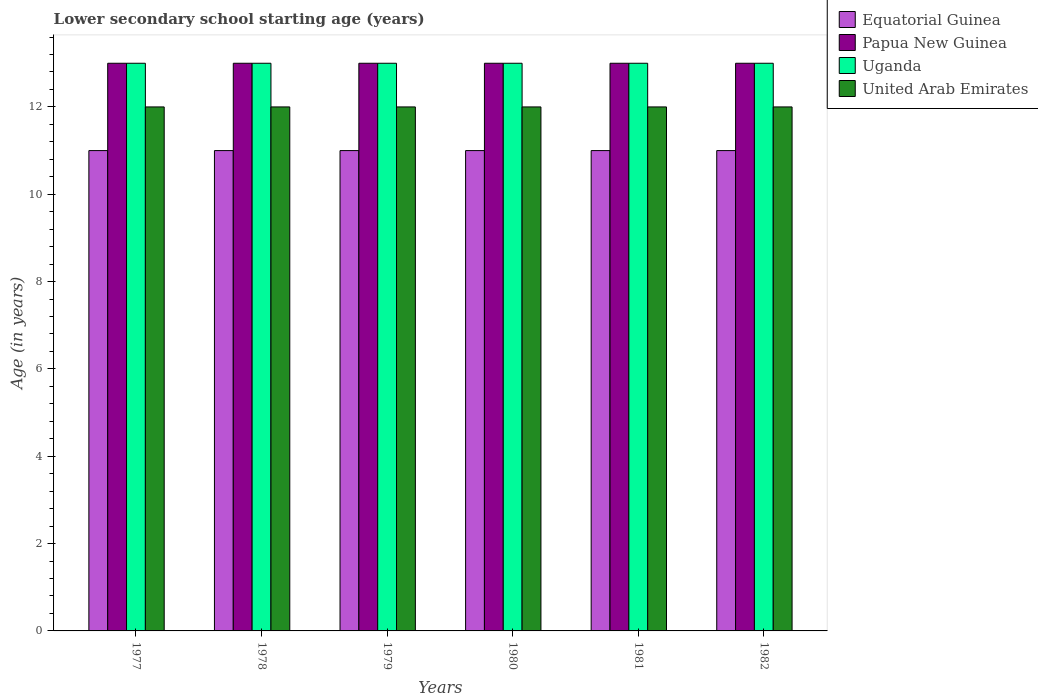How many different coloured bars are there?
Make the answer very short. 4. How many groups of bars are there?
Provide a succinct answer. 6. What is the label of the 6th group of bars from the left?
Ensure brevity in your answer.  1982. What is the lower secondary school starting age of children in Equatorial Guinea in 1978?
Your answer should be compact. 11. Across all years, what is the maximum lower secondary school starting age of children in Uganda?
Provide a succinct answer. 13. Across all years, what is the minimum lower secondary school starting age of children in Papua New Guinea?
Offer a terse response. 13. What is the total lower secondary school starting age of children in United Arab Emirates in the graph?
Offer a very short reply. 72. What is the difference between the lower secondary school starting age of children in Uganda in 1981 and the lower secondary school starting age of children in Equatorial Guinea in 1978?
Ensure brevity in your answer.  2. What is the average lower secondary school starting age of children in United Arab Emirates per year?
Your answer should be very brief. 12. In the year 1980, what is the difference between the lower secondary school starting age of children in Equatorial Guinea and lower secondary school starting age of children in Papua New Guinea?
Ensure brevity in your answer.  -2. What is the ratio of the lower secondary school starting age of children in Papua New Guinea in 1979 to that in 1980?
Make the answer very short. 1. Is the lower secondary school starting age of children in Equatorial Guinea in 1977 less than that in 1979?
Give a very brief answer. No. Is the difference between the lower secondary school starting age of children in Equatorial Guinea in 1980 and 1981 greater than the difference between the lower secondary school starting age of children in Papua New Guinea in 1980 and 1981?
Your answer should be compact. No. What is the difference between the highest and the second highest lower secondary school starting age of children in Uganda?
Offer a terse response. 0. What is the difference between the highest and the lowest lower secondary school starting age of children in United Arab Emirates?
Offer a terse response. 0. In how many years, is the lower secondary school starting age of children in Uganda greater than the average lower secondary school starting age of children in Uganda taken over all years?
Offer a very short reply. 0. What does the 3rd bar from the left in 1980 represents?
Offer a terse response. Uganda. What does the 2nd bar from the right in 1979 represents?
Your answer should be compact. Uganda. How many years are there in the graph?
Your answer should be very brief. 6. What is the difference between two consecutive major ticks on the Y-axis?
Keep it short and to the point. 2. Are the values on the major ticks of Y-axis written in scientific E-notation?
Your answer should be very brief. No. Does the graph contain any zero values?
Your answer should be compact. No. How many legend labels are there?
Your answer should be very brief. 4. What is the title of the graph?
Offer a terse response. Lower secondary school starting age (years). Does "Solomon Islands" appear as one of the legend labels in the graph?
Provide a short and direct response. No. What is the label or title of the X-axis?
Your answer should be compact. Years. What is the label or title of the Y-axis?
Ensure brevity in your answer.  Age (in years). What is the Age (in years) in Uganda in 1977?
Offer a terse response. 13. What is the Age (in years) in Papua New Guinea in 1978?
Provide a short and direct response. 13. What is the Age (in years) of Uganda in 1978?
Keep it short and to the point. 13. What is the Age (in years) of United Arab Emirates in 1978?
Offer a terse response. 12. What is the Age (in years) of Equatorial Guinea in 1979?
Ensure brevity in your answer.  11. What is the Age (in years) of Uganda in 1979?
Provide a succinct answer. 13. What is the Age (in years) of Papua New Guinea in 1980?
Offer a terse response. 13. What is the Age (in years) in United Arab Emirates in 1980?
Make the answer very short. 12. What is the Age (in years) of Papua New Guinea in 1981?
Give a very brief answer. 13. What is the Age (in years) in United Arab Emirates in 1981?
Your answer should be compact. 12. What is the Age (in years) of Equatorial Guinea in 1982?
Offer a terse response. 11. What is the Age (in years) in Papua New Guinea in 1982?
Your answer should be very brief. 13. What is the Age (in years) in United Arab Emirates in 1982?
Provide a short and direct response. 12. Across all years, what is the maximum Age (in years) in Papua New Guinea?
Keep it short and to the point. 13. Across all years, what is the maximum Age (in years) in United Arab Emirates?
Ensure brevity in your answer.  12. Across all years, what is the minimum Age (in years) in Equatorial Guinea?
Your answer should be compact. 11. Across all years, what is the minimum Age (in years) in Uganda?
Provide a short and direct response. 13. Across all years, what is the minimum Age (in years) of United Arab Emirates?
Your response must be concise. 12. What is the total Age (in years) in Equatorial Guinea in the graph?
Offer a very short reply. 66. What is the total Age (in years) in Uganda in the graph?
Make the answer very short. 78. What is the total Age (in years) in United Arab Emirates in the graph?
Provide a short and direct response. 72. What is the difference between the Age (in years) of Equatorial Guinea in 1977 and that in 1978?
Make the answer very short. 0. What is the difference between the Age (in years) of Uganda in 1977 and that in 1978?
Your response must be concise. 0. What is the difference between the Age (in years) in Papua New Guinea in 1977 and that in 1979?
Give a very brief answer. 0. What is the difference between the Age (in years) of Uganda in 1977 and that in 1979?
Give a very brief answer. 0. What is the difference between the Age (in years) in United Arab Emirates in 1977 and that in 1979?
Offer a very short reply. 0. What is the difference between the Age (in years) of Equatorial Guinea in 1977 and that in 1981?
Provide a short and direct response. 0. What is the difference between the Age (in years) of Papua New Guinea in 1977 and that in 1981?
Your answer should be very brief. 0. What is the difference between the Age (in years) of Uganda in 1977 and that in 1981?
Your response must be concise. 0. What is the difference between the Age (in years) in United Arab Emirates in 1977 and that in 1981?
Give a very brief answer. 0. What is the difference between the Age (in years) in Equatorial Guinea in 1977 and that in 1982?
Offer a very short reply. 0. What is the difference between the Age (in years) in Papua New Guinea in 1977 and that in 1982?
Offer a very short reply. 0. What is the difference between the Age (in years) of Uganda in 1977 and that in 1982?
Keep it short and to the point. 0. What is the difference between the Age (in years) in Equatorial Guinea in 1978 and that in 1979?
Make the answer very short. 0. What is the difference between the Age (in years) in Papua New Guinea in 1978 and that in 1979?
Ensure brevity in your answer.  0. What is the difference between the Age (in years) in Uganda in 1978 and that in 1979?
Offer a terse response. 0. What is the difference between the Age (in years) in United Arab Emirates in 1978 and that in 1979?
Keep it short and to the point. 0. What is the difference between the Age (in years) in Equatorial Guinea in 1978 and that in 1980?
Provide a short and direct response. 0. What is the difference between the Age (in years) of Papua New Guinea in 1978 and that in 1980?
Your response must be concise. 0. What is the difference between the Age (in years) of Uganda in 1978 and that in 1980?
Your answer should be very brief. 0. What is the difference between the Age (in years) in Papua New Guinea in 1978 and that in 1981?
Ensure brevity in your answer.  0. What is the difference between the Age (in years) of United Arab Emirates in 1978 and that in 1981?
Make the answer very short. 0. What is the difference between the Age (in years) in Equatorial Guinea in 1978 and that in 1982?
Provide a short and direct response. 0. What is the difference between the Age (in years) in Equatorial Guinea in 1979 and that in 1980?
Ensure brevity in your answer.  0. What is the difference between the Age (in years) in Uganda in 1979 and that in 1980?
Provide a succinct answer. 0. What is the difference between the Age (in years) of Equatorial Guinea in 1979 and that in 1981?
Ensure brevity in your answer.  0. What is the difference between the Age (in years) of Uganda in 1979 and that in 1981?
Offer a very short reply. 0. What is the difference between the Age (in years) in United Arab Emirates in 1979 and that in 1981?
Your answer should be compact. 0. What is the difference between the Age (in years) in Papua New Guinea in 1979 and that in 1982?
Make the answer very short. 0. What is the difference between the Age (in years) of United Arab Emirates in 1979 and that in 1982?
Ensure brevity in your answer.  0. What is the difference between the Age (in years) of United Arab Emirates in 1980 and that in 1981?
Your answer should be compact. 0. What is the difference between the Age (in years) of Equatorial Guinea in 1980 and that in 1982?
Keep it short and to the point. 0. What is the difference between the Age (in years) of Papua New Guinea in 1980 and that in 1982?
Offer a terse response. 0. What is the difference between the Age (in years) of Uganda in 1980 and that in 1982?
Offer a terse response. 0. What is the difference between the Age (in years) of United Arab Emirates in 1980 and that in 1982?
Make the answer very short. 0. What is the difference between the Age (in years) of Equatorial Guinea in 1981 and that in 1982?
Make the answer very short. 0. What is the difference between the Age (in years) of Equatorial Guinea in 1977 and the Age (in years) of Uganda in 1978?
Your response must be concise. -2. What is the difference between the Age (in years) of Equatorial Guinea in 1977 and the Age (in years) of United Arab Emirates in 1978?
Your answer should be compact. -1. What is the difference between the Age (in years) in Papua New Guinea in 1977 and the Age (in years) in United Arab Emirates in 1978?
Your response must be concise. 1. What is the difference between the Age (in years) of Equatorial Guinea in 1977 and the Age (in years) of Papua New Guinea in 1979?
Your answer should be very brief. -2. What is the difference between the Age (in years) of Papua New Guinea in 1977 and the Age (in years) of Uganda in 1979?
Provide a succinct answer. 0. What is the difference between the Age (in years) in Papua New Guinea in 1977 and the Age (in years) in United Arab Emirates in 1979?
Your answer should be very brief. 1. What is the difference between the Age (in years) in Uganda in 1977 and the Age (in years) in United Arab Emirates in 1979?
Your response must be concise. 1. What is the difference between the Age (in years) of Equatorial Guinea in 1977 and the Age (in years) of Papua New Guinea in 1980?
Offer a very short reply. -2. What is the difference between the Age (in years) in Equatorial Guinea in 1977 and the Age (in years) in Uganda in 1980?
Your answer should be compact. -2. What is the difference between the Age (in years) of Papua New Guinea in 1977 and the Age (in years) of Uganda in 1980?
Provide a short and direct response. 0. What is the difference between the Age (in years) in Equatorial Guinea in 1977 and the Age (in years) in Papua New Guinea in 1981?
Provide a short and direct response. -2. What is the difference between the Age (in years) of Equatorial Guinea in 1977 and the Age (in years) of United Arab Emirates in 1981?
Make the answer very short. -1. What is the difference between the Age (in years) of Papua New Guinea in 1977 and the Age (in years) of Uganda in 1981?
Your answer should be compact. 0. What is the difference between the Age (in years) of Papua New Guinea in 1977 and the Age (in years) of United Arab Emirates in 1981?
Keep it short and to the point. 1. What is the difference between the Age (in years) in Equatorial Guinea in 1977 and the Age (in years) in Uganda in 1982?
Make the answer very short. -2. What is the difference between the Age (in years) of Equatorial Guinea in 1977 and the Age (in years) of United Arab Emirates in 1982?
Make the answer very short. -1. What is the difference between the Age (in years) of Uganda in 1977 and the Age (in years) of United Arab Emirates in 1982?
Your response must be concise. 1. What is the difference between the Age (in years) of Equatorial Guinea in 1978 and the Age (in years) of United Arab Emirates in 1979?
Give a very brief answer. -1. What is the difference between the Age (in years) of Papua New Guinea in 1978 and the Age (in years) of United Arab Emirates in 1979?
Your answer should be very brief. 1. What is the difference between the Age (in years) in Uganda in 1978 and the Age (in years) in United Arab Emirates in 1979?
Offer a very short reply. 1. What is the difference between the Age (in years) in Equatorial Guinea in 1978 and the Age (in years) in Papua New Guinea in 1980?
Offer a terse response. -2. What is the difference between the Age (in years) of Equatorial Guinea in 1978 and the Age (in years) of United Arab Emirates in 1980?
Provide a short and direct response. -1. What is the difference between the Age (in years) in Papua New Guinea in 1978 and the Age (in years) in Uganda in 1980?
Your answer should be compact. 0. What is the difference between the Age (in years) in Papua New Guinea in 1978 and the Age (in years) in United Arab Emirates in 1980?
Offer a very short reply. 1. What is the difference between the Age (in years) of Equatorial Guinea in 1978 and the Age (in years) of United Arab Emirates in 1981?
Make the answer very short. -1. What is the difference between the Age (in years) in Equatorial Guinea in 1978 and the Age (in years) in United Arab Emirates in 1982?
Make the answer very short. -1. What is the difference between the Age (in years) of Papua New Guinea in 1978 and the Age (in years) of Uganda in 1982?
Make the answer very short. 0. What is the difference between the Age (in years) of Uganda in 1978 and the Age (in years) of United Arab Emirates in 1982?
Your answer should be very brief. 1. What is the difference between the Age (in years) of Equatorial Guinea in 1979 and the Age (in years) of United Arab Emirates in 1980?
Offer a very short reply. -1. What is the difference between the Age (in years) in Papua New Guinea in 1979 and the Age (in years) in Uganda in 1980?
Your answer should be very brief. 0. What is the difference between the Age (in years) in Papua New Guinea in 1979 and the Age (in years) in United Arab Emirates in 1980?
Offer a very short reply. 1. What is the difference between the Age (in years) of Equatorial Guinea in 1979 and the Age (in years) of Uganda in 1981?
Your answer should be very brief. -2. What is the difference between the Age (in years) of Papua New Guinea in 1979 and the Age (in years) of United Arab Emirates in 1981?
Provide a short and direct response. 1. What is the difference between the Age (in years) of Uganda in 1979 and the Age (in years) of United Arab Emirates in 1981?
Offer a very short reply. 1. What is the difference between the Age (in years) in Equatorial Guinea in 1979 and the Age (in years) in Papua New Guinea in 1982?
Provide a succinct answer. -2. What is the difference between the Age (in years) of Equatorial Guinea in 1979 and the Age (in years) of Uganda in 1982?
Provide a short and direct response. -2. What is the difference between the Age (in years) of Equatorial Guinea in 1979 and the Age (in years) of United Arab Emirates in 1982?
Keep it short and to the point. -1. What is the difference between the Age (in years) in Uganda in 1979 and the Age (in years) in United Arab Emirates in 1982?
Offer a very short reply. 1. What is the difference between the Age (in years) in Equatorial Guinea in 1980 and the Age (in years) in Papua New Guinea in 1981?
Offer a terse response. -2. What is the difference between the Age (in years) of Equatorial Guinea in 1980 and the Age (in years) of United Arab Emirates in 1981?
Give a very brief answer. -1. What is the difference between the Age (in years) of Equatorial Guinea in 1980 and the Age (in years) of Uganda in 1982?
Provide a succinct answer. -2. What is the difference between the Age (in years) of Papua New Guinea in 1980 and the Age (in years) of Uganda in 1982?
Offer a very short reply. 0. What is the difference between the Age (in years) in Papua New Guinea in 1980 and the Age (in years) in United Arab Emirates in 1982?
Keep it short and to the point. 1. What is the difference between the Age (in years) of Uganda in 1980 and the Age (in years) of United Arab Emirates in 1982?
Your response must be concise. 1. What is the difference between the Age (in years) of Papua New Guinea in 1981 and the Age (in years) of Uganda in 1982?
Ensure brevity in your answer.  0. What is the difference between the Age (in years) of Uganda in 1981 and the Age (in years) of United Arab Emirates in 1982?
Your answer should be compact. 1. What is the average Age (in years) in Equatorial Guinea per year?
Make the answer very short. 11. What is the average Age (in years) in United Arab Emirates per year?
Offer a terse response. 12. In the year 1977, what is the difference between the Age (in years) of Papua New Guinea and Age (in years) of United Arab Emirates?
Provide a short and direct response. 1. In the year 1978, what is the difference between the Age (in years) of Equatorial Guinea and Age (in years) of Papua New Guinea?
Keep it short and to the point. -2. In the year 1978, what is the difference between the Age (in years) in Equatorial Guinea and Age (in years) in United Arab Emirates?
Offer a terse response. -1. In the year 1978, what is the difference between the Age (in years) of Papua New Guinea and Age (in years) of Uganda?
Ensure brevity in your answer.  0. In the year 1979, what is the difference between the Age (in years) of Equatorial Guinea and Age (in years) of Papua New Guinea?
Ensure brevity in your answer.  -2. In the year 1979, what is the difference between the Age (in years) in Equatorial Guinea and Age (in years) in Uganda?
Your answer should be very brief. -2. In the year 1980, what is the difference between the Age (in years) in Equatorial Guinea and Age (in years) in Uganda?
Provide a short and direct response. -2. In the year 1980, what is the difference between the Age (in years) of Equatorial Guinea and Age (in years) of United Arab Emirates?
Keep it short and to the point. -1. In the year 1980, what is the difference between the Age (in years) of Papua New Guinea and Age (in years) of Uganda?
Give a very brief answer. 0. In the year 1980, what is the difference between the Age (in years) in Papua New Guinea and Age (in years) in United Arab Emirates?
Give a very brief answer. 1. In the year 1981, what is the difference between the Age (in years) in Equatorial Guinea and Age (in years) in Uganda?
Make the answer very short. -2. In the year 1981, what is the difference between the Age (in years) in Papua New Guinea and Age (in years) in United Arab Emirates?
Your answer should be very brief. 1. In the year 1982, what is the difference between the Age (in years) in Equatorial Guinea and Age (in years) in Papua New Guinea?
Offer a terse response. -2. In the year 1982, what is the difference between the Age (in years) of Uganda and Age (in years) of United Arab Emirates?
Offer a very short reply. 1. What is the ratio of the Age (in years) of Equatorial Guinea in 1977 to that in 1978?
Your response must be concise. 1. What is the ratio of the Age (in years) of United Arab Emirates in 1977 to that in 1978?
Provide a succinct answer. 1. What is the ratio of the Age (in years) in Papua New Guinea in 1977 to that in 1979?
Provide a succinct answer. 1. What is the ratio of the Age (in years) of Uganda in 1977 to that in 1979?
Ensure brevity in your answer.  1. What is the ratio of the Age (in years) of United Arab Emirates in 1977 to that in 1979?
Provide a short and direct response. 1. What is the ratio of the Age (in years) in Equatorial Guinea in 1977 to that in 1980?
Your answer should be compact. 1. What is the ratio of the Age (in years) of Papua New Guinea in 1977 to that in 1980?
Make the answer very short. 1. What is the ratio of the Age (in years) of United Arab Emirates in 1977 to that in 1980?
Offer a terse response. 1. What is the ratio of the Age (in years) in United Arab Emirates in 1977 to that in 1981?
Offer a very short reply. 1. What is the ratio of the Age (in years) in Papua New Guinea in 1977 to that in 1982?
Give a very brief answer. 1. What is the ratio of the Age (in years) of Uganda in 1977 to that in 1982?
Keep it short and to the point. 1. What is the ratio of the Age (in years) in Papua New Guinea in 1978 to that in 1979?
Make the answer very short. 1. What is the ratio of the Age (in years) in Uganda in 1978 to that in 1979?
Give a very brief answer. 1. What is the ratio of the Age (in years) of Equatorial Guinea in 1978 to that in 1980?
Give a very brief answer. 1. What is the ratio of the Age (in years) in Papua New Guinea in 1978 to that in 1980?
Your response must be concise. 1. What is the ratio of the Age (in years) of Uganda in 1978 to that in 1980?
Make the answer very short. 1. What is the ratio of the Age (in years) of United Arab Emirates in 1978 to that in 1980?
Offer a very short reply. 1. What is the ratio of the Age (in years) of Uganda in 1978 to that in 1981?
Make the answer very short. 1. What is the ratio of the Age (in years) in Equatorial Guinea in 1978 to that in 1982?
Offer a very short reply. 1. What is the ratio of the Age (in years) in Papua New Guinea in 1978 to that in 1982?
Your answer should be very brief. 1. What is the ratio of the Age (in years) in Uganda in 1978 to that in 1982?
Ensure brevity in your answer.  1. What is the ratio of the Age (in years) in United Arab Emirates in 1978 to that in 1982?
Ensure brevity in your answer.  1. What is the ratio of the Age (in years) in Equatorial Guinea in 1979 to that in 1980?
Keep it short and to the point. 1. What is the ratio of the Age (in years) of Equatorial Guinea in 1979 to that in 1981?
Your answer should be very brief. 1. What is the ratio of the Age (in years) in Uganda in 1979 to that in 1981?
Give a very brief answer. 1. What is the ratio of the Age (in years) in United Arab Emirates in 1979 to that in 1981?
Keep it short and to the point. 1. What is the ratio of the Age (in years) in Papua New Guinea in 1979 to that in 1982?
Make the answer very short. 1. What is the ratio of the Age (in years) of Uganda in 1979 to that in 1982?
Give a very brief answer. 1. What is the ratio of the Age (in years) of United Arab Emirates in 1979 to that in 1982?
Your answer should be very brief. 1. What is the ratio of the Age (in years) in United Arab Emirates in 1980 to that in 1982?
Your answer should be very brief. 1. What is the ratio of the Age (in years) in Equatorial Guinea in 1981 to that in 1982?
Provide a short and direct response. 1. What is the difference between the highest and the second highest Age (in years) in Equatorial Guinea?
Your answer should be very brief. 0. What is the difference between the highest and the lowest Age (in years) in Equatorial Guinea?
Give a very brief answer. 0. What is the difference between the highest and the lowest Age (in years) in Papua New Guinea?
Offer a terse response. 0. 